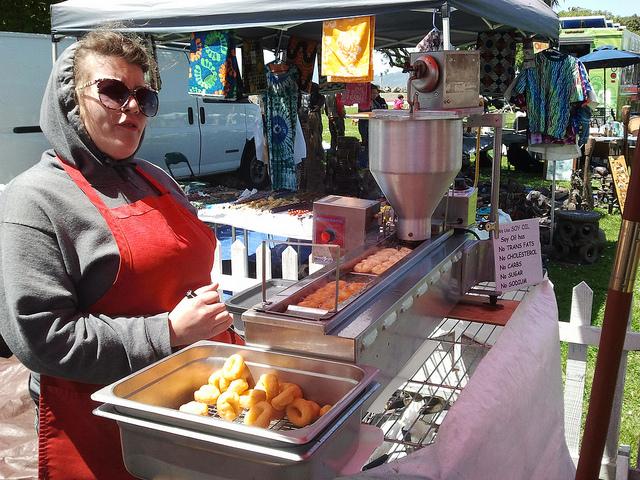Is this being done in the back of the house?
Answer briefly. No. What is covering the woman's eyes?
Give a very brief answer. Sunglasses. What color is her apron?
Write a very short answer. Red. Is this market in the U.S.?
Concise answer only. Yes. What is the man with the orange pants eating?
Be succinct. Nothing. Why is this lady wearing an apron?
Concise answer only. Cooking. What food is this woman selling?
Short answer required. Donuts. What kind of market is this?
Give a very brief answer. Flea market. 